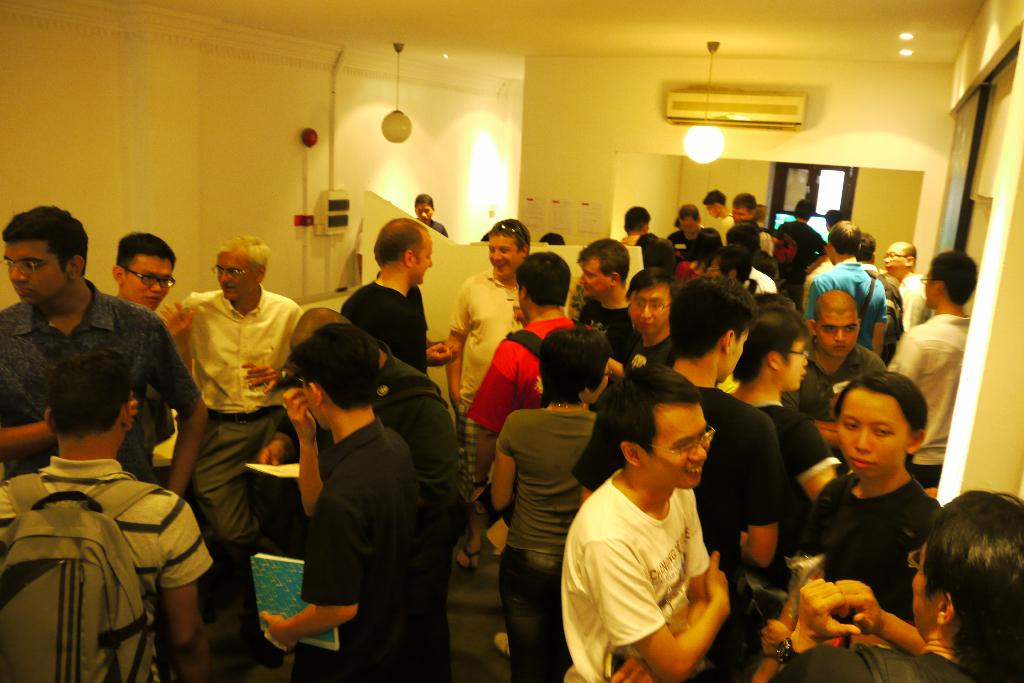Who or what can be seen in the image? There are people in the image. What is visible in the background of the image? There is a wall in the background of the image. What can be used for illumination in the image? There are lights visible in the image. What feature allows for a view of the outside in the image? There is a window in the image. What type of flesh can be seen hanging from the wall in the image? There is no flesh hanging from the wall in the image; it only features people, a wall, lights, and a window. 